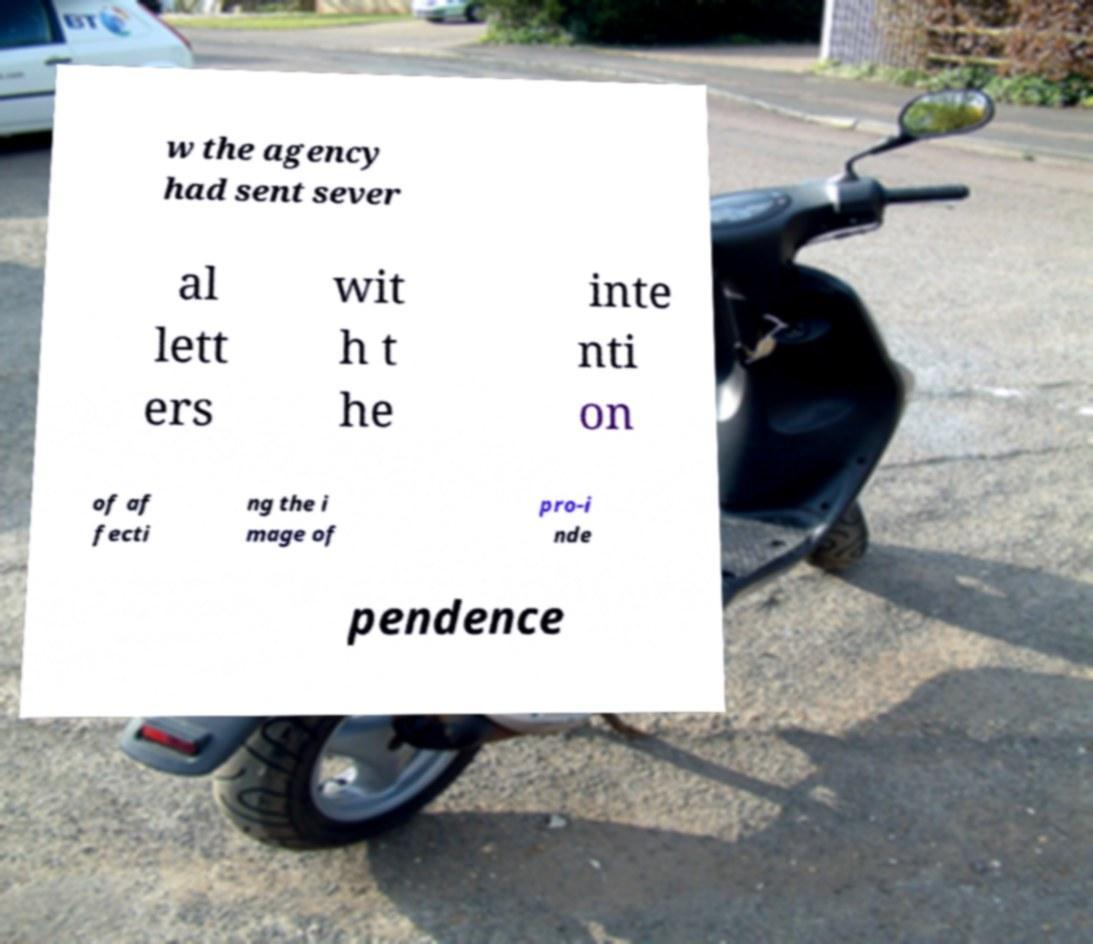For documentation purposes, I need the text within this image transcribed. Could you provide that? w the agency had sent sever al lett ers wit h t he inte nti on of af fecti ng the i mage of pro-i nde pendence 